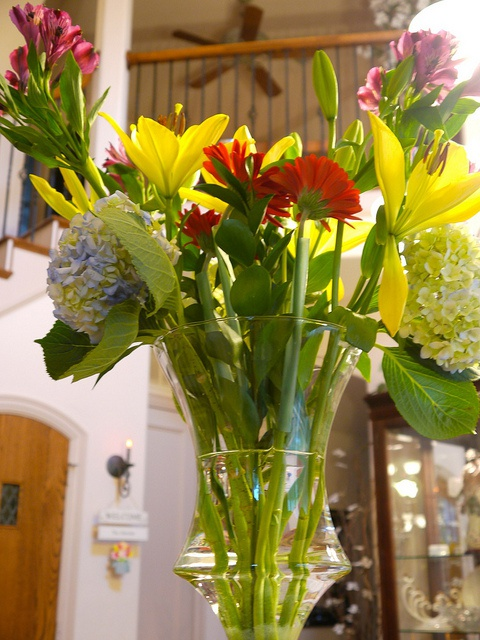Describe the objects in this image and their specific colors. I can see potted plant in tan, olive, darkgreen, and gold tones and vase in tan, olive, and darkgreen tones in this image. 